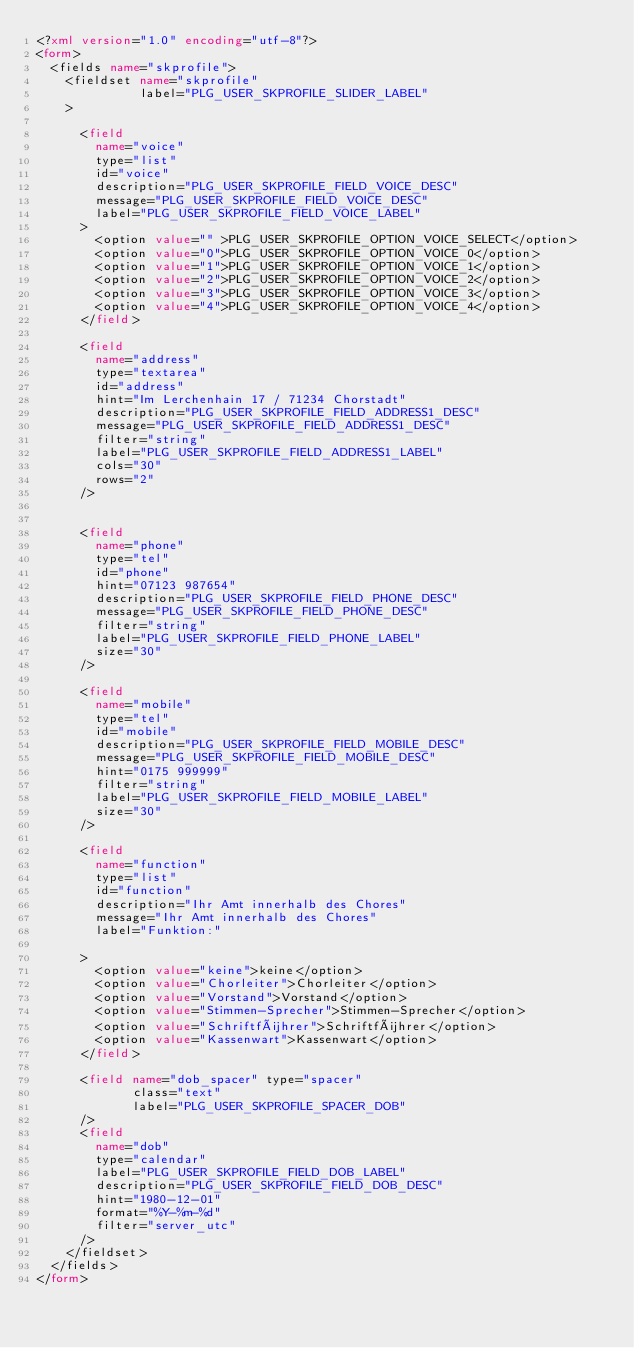Convert code to text. <code><loc_0><loc_0><loc_500><loc_500><_XML_><?xml version="1.0" encoding="utf-8"?>
<form>
  <fields name="skprofile">
    <fieldset name="skprofile"
              label="PLG_USER_SKPROFILE_SLIDER_LABEL"
    >
      
      <field
        name="voice"
        type="list"
        id="voice"
        description="PLG_USER_SKPROFILE_FIELD_VOICE_DESC"
        message="PLG_USER_SKPROFILE_FIELD_VOICE_DESC"
        label="PLG_USER_SKPROFILE_FIELD_VOICE_LABEL"
      >          
        <option value="" >PLG_USER_SKPROFILE_OPTION_VOICE_SELECT</option>
        <option value="0">PLG_USER_SKPROFILE_OPTION_VOICE_0</option>
        <option value="1">PLG_USER_SKPROFILE_OPTION_VOICE_1</option>
        <option value="2">PLG_USER_SKPROFILE_OPTION_VOICE_2</option>
        <option value="3">PLG_USER_SKPROFILE_OPTION_VOICE_3</option>
        <option value="4">PLG_USER_SKPROFILE_OPTION_VOICE_4</option>
      </field>
            
      <field
        name="address"
        type="textarea"
        id="address"
        hint="Im Lerchenhain 17 / 71234 Chorstadt"
        description="PLG_USER_SKPROFILE_FIELD_ADDRESS1_DESC"
        message="PLG_USER_SKPROFILE_FIELD_ADDRESS1_DESC"
        filter="string"
        label="PLG_USER_SKPROFILE_FIELD_ADDRESS1_LABEL"
        cols="30"
        rows="2"
      />


      <field
        name="phone"
        type="tel"
        id="phone"
        hint="07123 987654"
        description="PLG_USER_SKPROFILE_FIELD_PHONE_DESC"
        message="PLG_USER_SKPROFILE_FIELD_PHONE_DESC"
        filter="string"
        label="PLG_USER_SKPROFILE_FIELD_PHONE_LABEL"
        size="30"
      />
            
      <field
        name="mobile"
        type="tel"
        id="mobile"
        description="PLG_USER_SKPROFILE_FIELD_MOBILE_DESC"
        message="PLG_USER_SKPROFILE_FIELD_MOBILE_DESC"
        hint="0175 999999"
        filter="string"
        label="PLG_USER_SKPROFILE_FIELD_MOBILE_LABEL"
        size="30"
      />
      
      <field
        name="function"
        type="list"
        id="function"
        description="Ihr Amt innerhalb des Chores"
        message="Ihr Amt innerhalb des Chores"
        label="Funktion:"

      >          
        <option value="keine">keine</option>
        <option value="Chorleiter">Chorleiter</option>
        <option value="Vorstand">Vorstand</option>
        <option value="Stimmen-Sprecher">Stimmen-Sprecher</option>
        <option value="Schriftführer">Schriftführer</option>
        <option value="Kassenwart">Kassenwart</option>        
      </field>

      <field name="dob_spacer" type="spacer"
             class="text"
             label="PLG_USER_SKPROFILE_SPACER_DOB"
      />
      <field
        name="dob"
        type="calendar"
        label="PLG_USER_SKPROFILE_FIELD_DOB_LABEL"
        description="PLG_USER_SKPROFILE_FIELD_DOB_DESC"
        hint="1980-12-01"
        format="%Y-%m-%d"
        filter="server_utc"
      />
    </fieldset>
  </fields>
</form>
</code> 